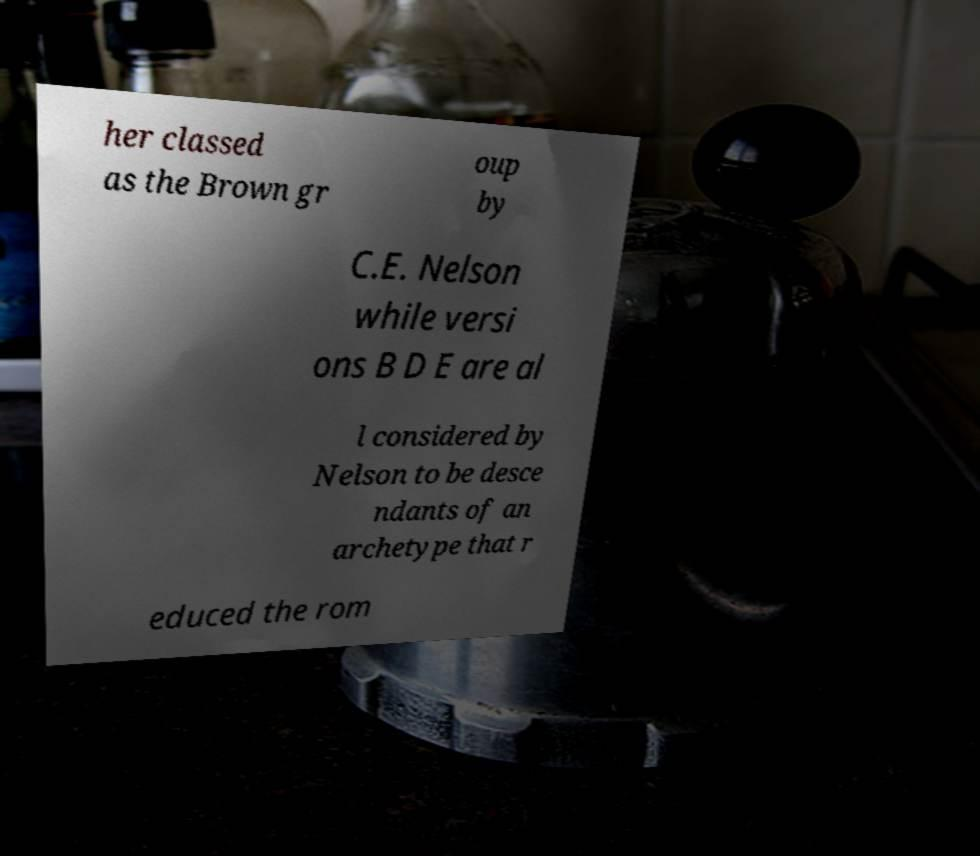Please read and relay the text visible in this image. What does it say? her classed as the Brown gr oup by C.E. Nelson while versi ons B D E are al l considered by Nelson to be desce ndants of an archetype that r educed the rom 